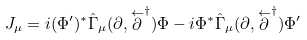<formula> <loc_0><loc_0><loc_500><loc_500>J _ { \mu } = i ( \Phi ^ { \prime } ) ^ { * } \hat { \Gamma } _ { \mu } ( \partial , \stackrel { \leftarrow } { \partial } ^ { \dagger } ) \Phi - i \Phi ^ { * } \hat { \Gamma } _ { \mu } ( \partial , \stackrel { \leftarrow } { \partial } ^ { \dagger } ) \Phi ^ { \prime }</formula> 